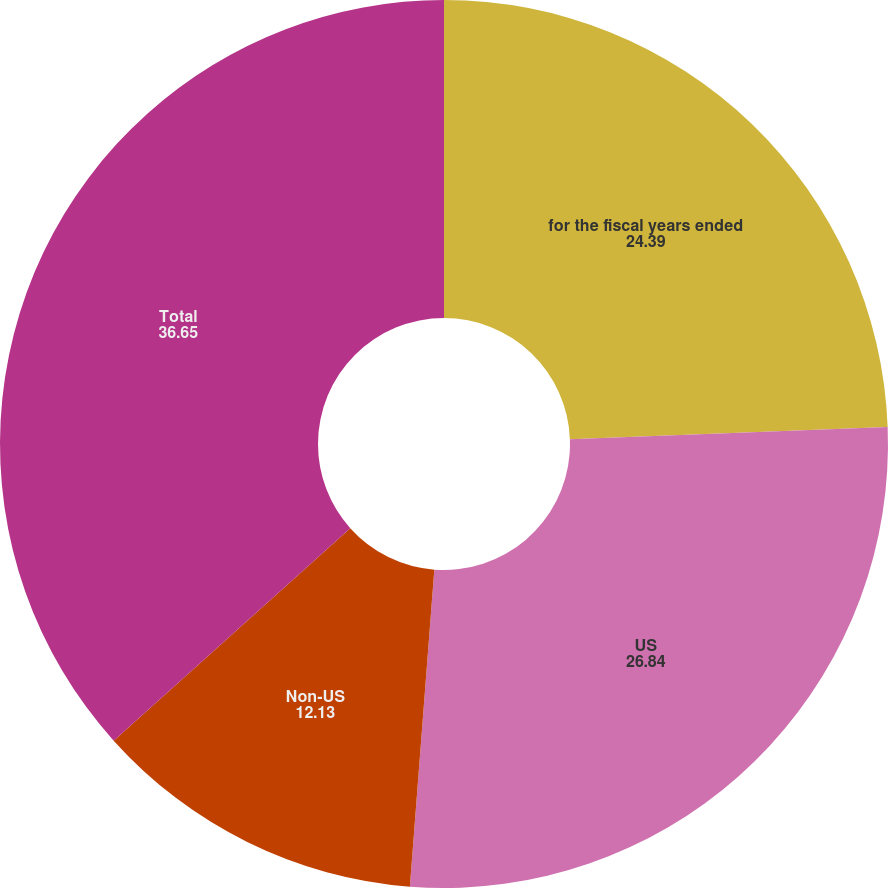Convert chart to OTSL. <chart><loc_0><loc_0><loc_500><loc_500><pie_chart><fcel>for the fiscal years ended<fcel>US<fcel>Non-US<fcel>Total<nl><fcel>24.39%<fcel>26.84%<fcel>12.13%<fcel>36.65%<nl></chart> 